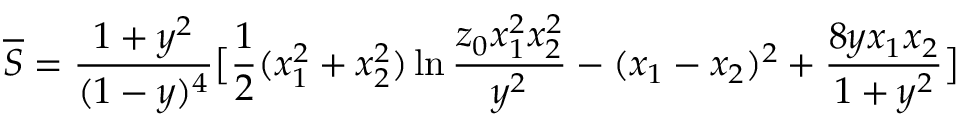<formula> <loc_0><loc_0><loc_500><loc_500>\overline { S } = \frac { 1 + y ^ { 2 } } { ( 1 - y ) ^ { 4 } } \left [ \frac { 1 } { 2 } ( x _ { 1 } ^ { 2 } + x _ { 2 } ^ { 2 } ) \ln \frac { z _ { 0 } x _ { 1 } ^ { 2 } x _ { 2 } ^ { 2 } } { y ^ { 2 } } - ( x _ { 1 } - x _ { 2 } ) ^ { 2 } + \frac { 8 y x _ { 1 } x _ { 2 } } { 1 + y ^ { 2 } } \right ]</formula> 